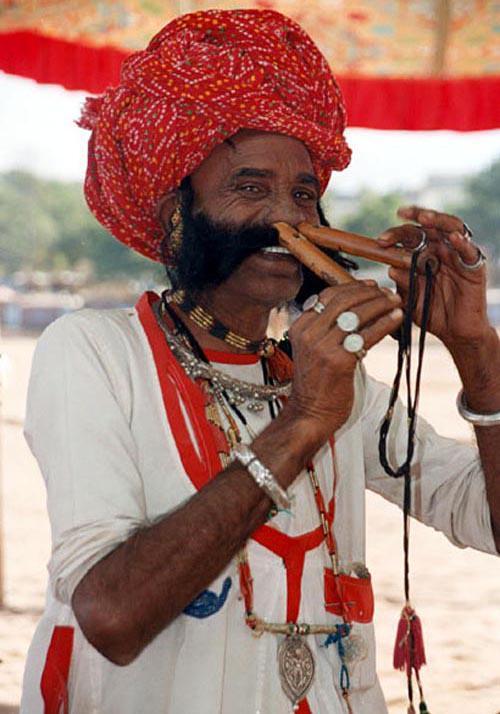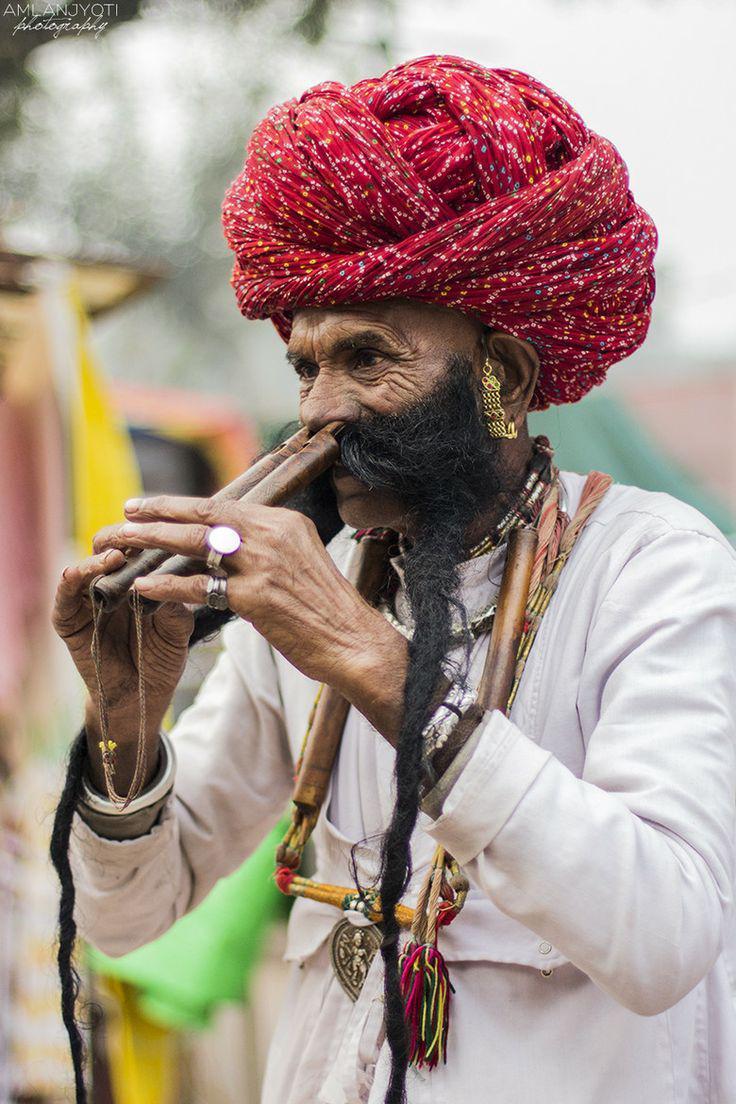The first image is the image on the left, the second image is the image on the right. For the images shown, is this caption "There is a man playing two nose flutes in each image" true? Answer yes or no. Yes. The first image is the image on the left, the second image is the image on the right. Considering the images on both sides, is "Each image shows a man holding at least one flute to a nostril, but only the left image features a man in a red turban and bushy dark facial hair holding two flutes to his nostrils." valid? Answer yes or no. No. 